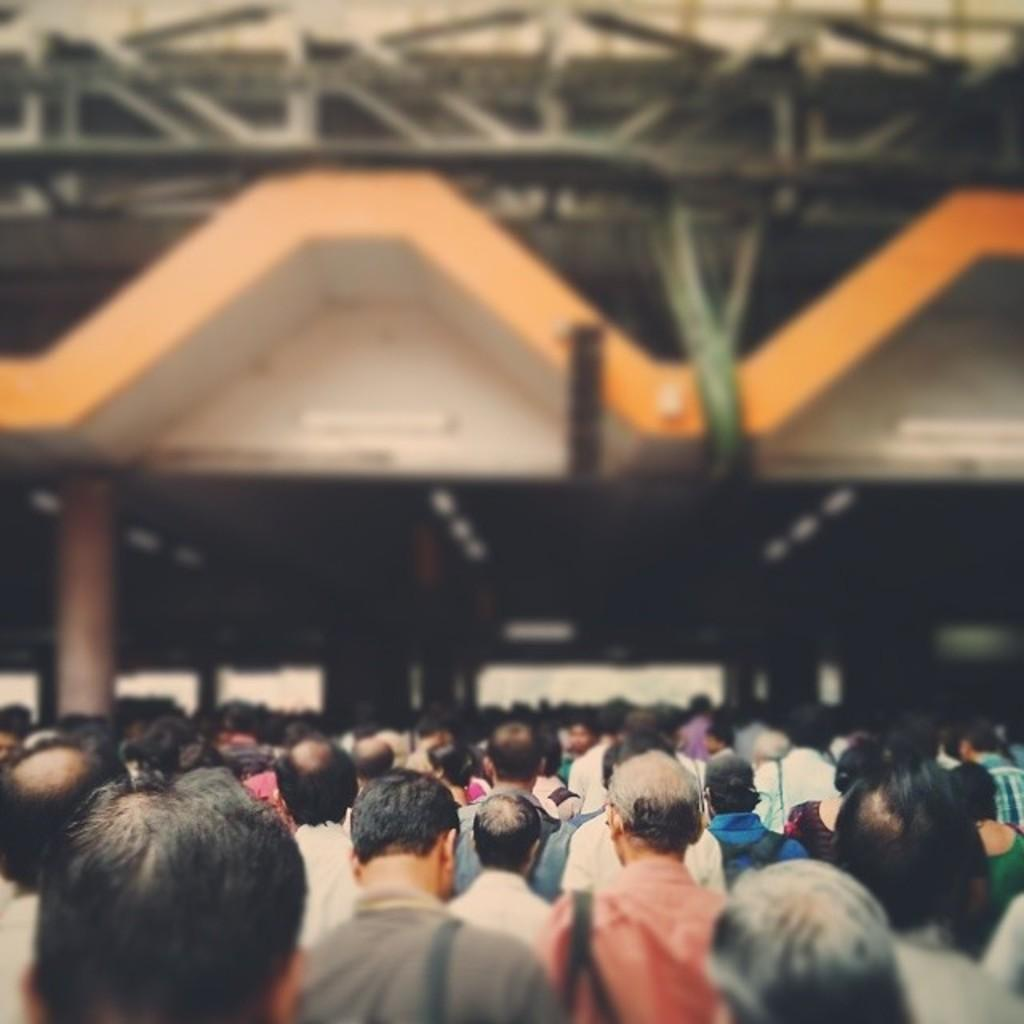What can be seen in the image? There are people standing in the image. What is the background of the image? There is a wall in the image. What type of insect is crawling on the edge of the wall in the image? There is no insect present on the wall in the image. 